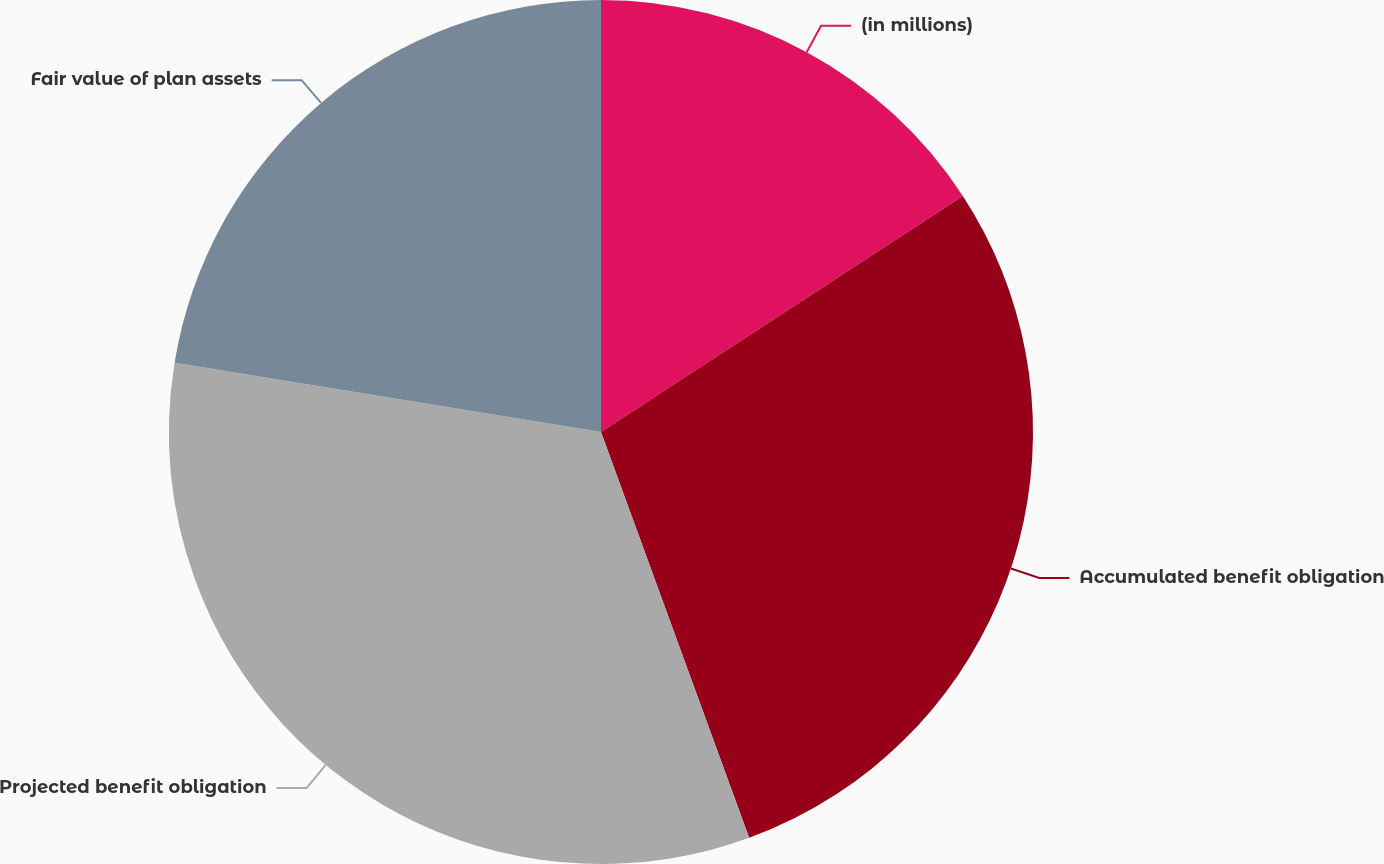Convert chart to OTSL. <chart><loc_0><loc_0><loc_500><loc_500><pie_chart><fcel>(in millions)<fcel>Accumulated benefit obligation<fcel>Projected benefit obligation<fcel>Fair value of plan assets<nl><fcel>15.8%<fcel>28.63%<fcel>33.13%<fcel>22.44%<nl></chart> 